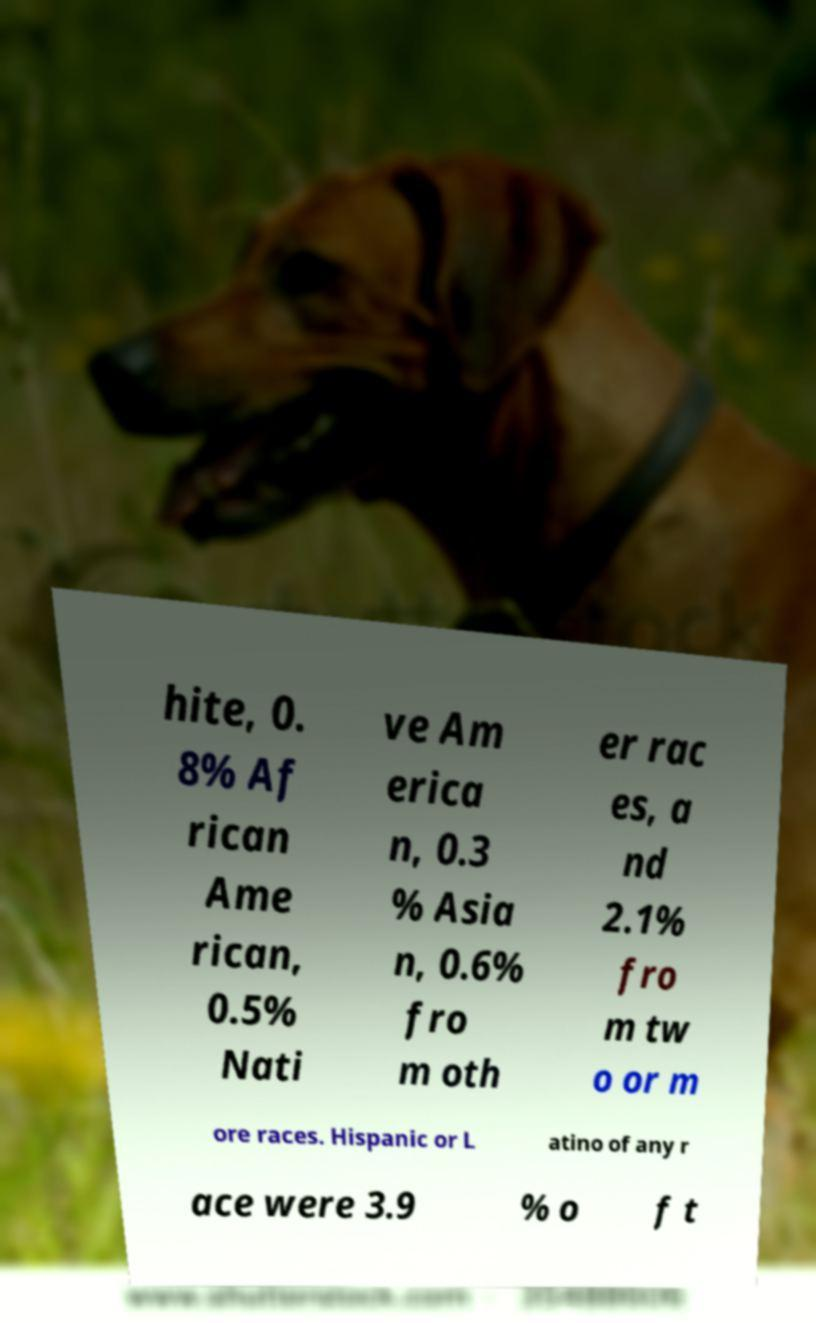For documentation purposes, I need the text within this image transcribed. Could you provide that? hite, 0. 8% Af rican Ame rican, 0.5% Nati ve Am erica n, 0.3 % Asia n, 0.6% fro m oth er rac es, a nd 2.1% fro m tw o or m ore races. Hispanic or L atino of any r ace were 3.9 % o f t 